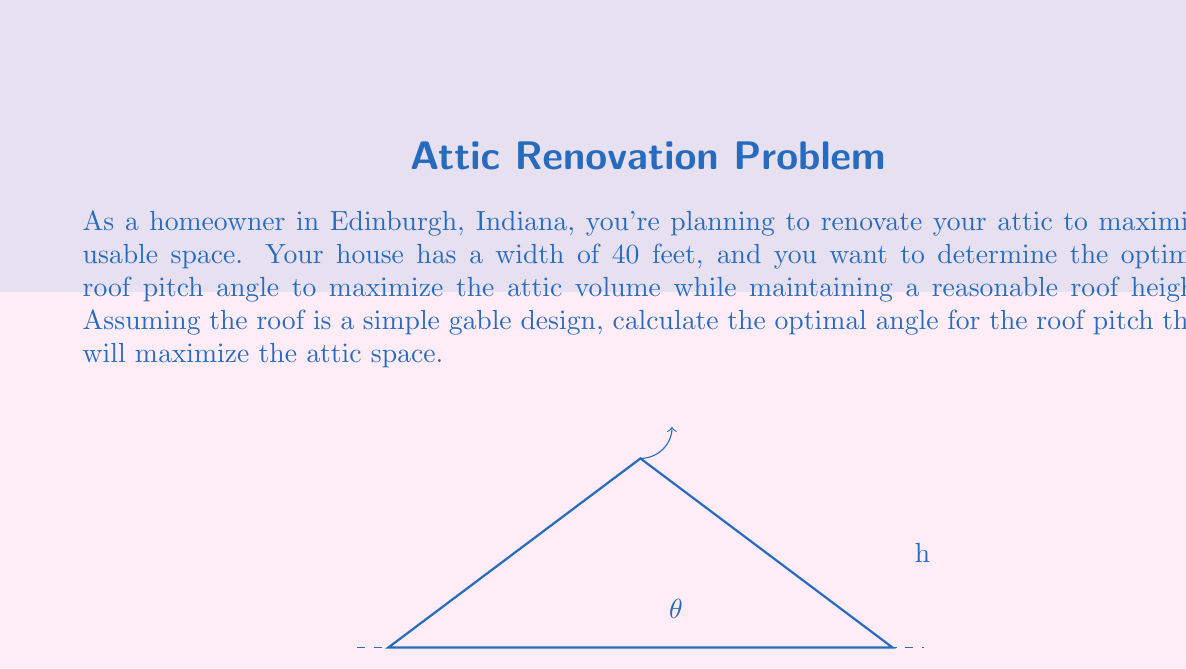Could you help me with this problem? Let's approach this step-by-step:

1) The volume of the attic space can be modeled as a triangular prism. The cross-sectional area of this prism is a triangle.

2) If we denote the angle of the roof pitch as $\theta$ and the height of the roof as $h$, we can express the area of the triangle as:

   $$A = \frac{1}{2} \cdot 40 \cdot h = 20h$$

3) We can express $h$ in terms of $\theta$:

   $$h = 20 \tan(\theta)$$

4) Substituting this into our area formula:

   $$A = 20 \cdot 20 \tan(\theta) = 400 \tan(\theta)$$

5) The volume of the attic will be this area multiplied by the length of the house. Since we're maximizing the area, we can focus on maximizing $\tan(\theta)$.

6) However, as $\theta$ increases, the height of the roof also increases, which may not be practical or allowed by local building codes. We need to find a balance.

7) In practice, the optimal angle for maximizing usable attic space while maintaining a reasonable roof height is often considered to be around 45°.

8) At 45°, $\tan(\theta) = 1$, which gives us a simple and effective solution.

9) With $\theta = 45°$, the height of the roof at the peak would be:

   $$h = 20 \tan(45°) = 20 \cdot 1 = 20\text{ ft}$$

This provides a good balance between maximizing attic space and maintaining a reasonable roof height.
Answer: 45° 